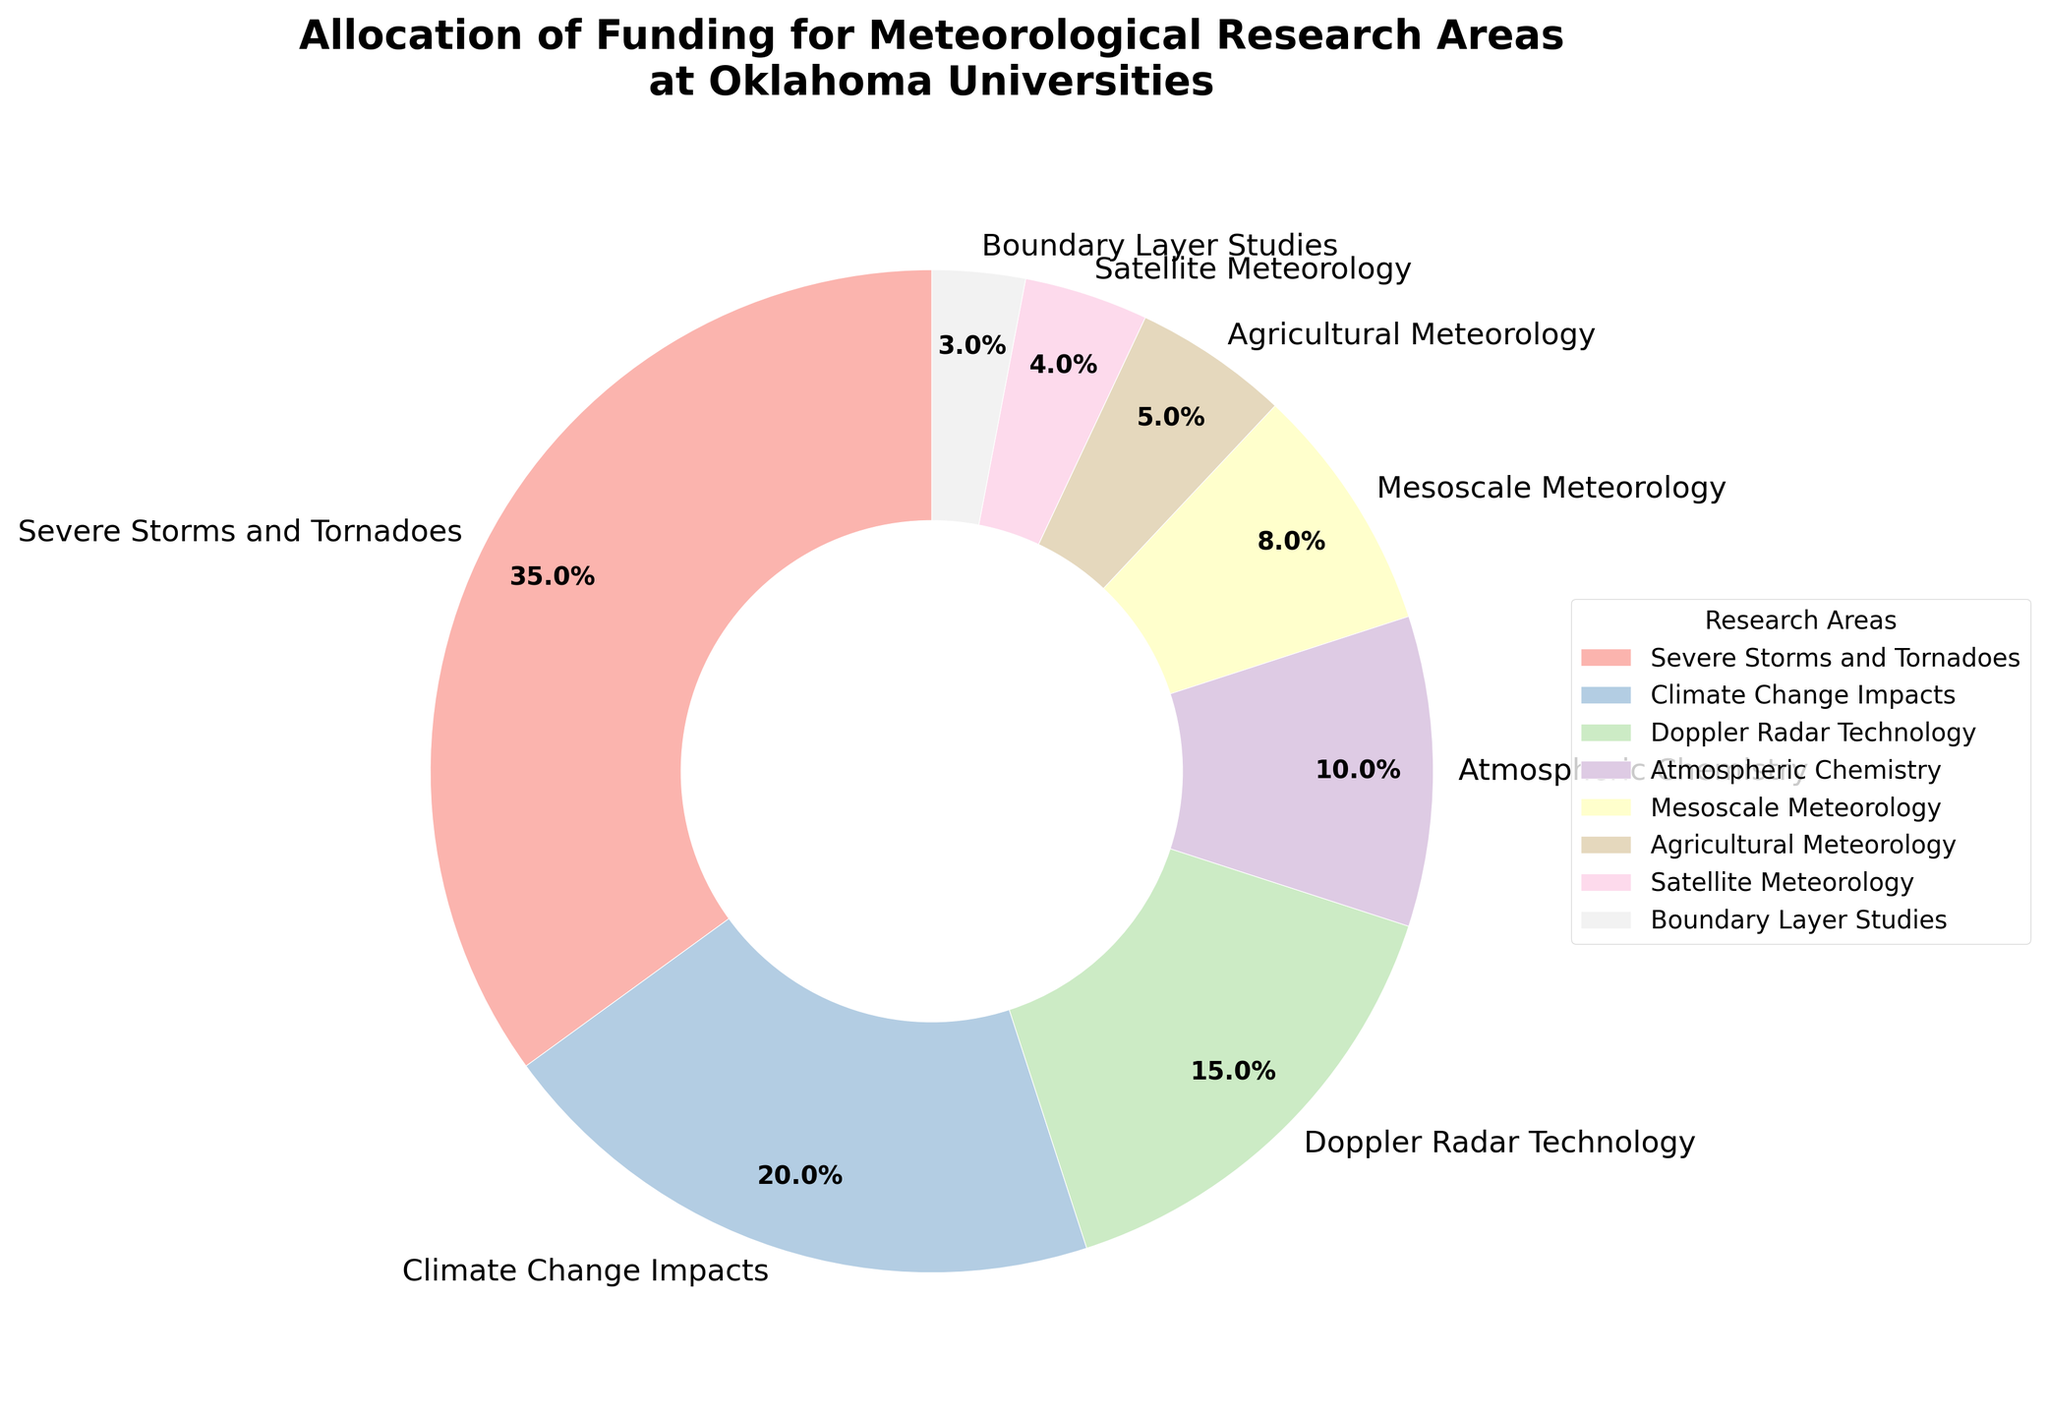Which research area received the highest funding allocation? The figure shows that Severe Storms and Tornadoes received the largest slice of the pie chart, indicating the highest funding allocation.
Answer: Severe Storms and Tornadoes Compare the funding allocations for Doppler Radar Technology and Boundary Layer Studies. Which one is higher and by how much? Doppler Radar Technology received 15% funding, while Boundary Layer Studies received 3%. The difference in allocation is 15% - 3% = 12%.
Answer: Doppler Radar Technology by 12% What is the combined funding allocation for Climate Change Impacts and Agricultural Meteorology? We sum the percentages for Climate Change Impacts (20%) and Agricultural Meteorology (5%): 20% + 5% = 25%.
Answer: 25% Out of the total funding, what percentage is allocated to Mesoscale Meteorology and Satellite Meteorology combined? Adding the funding percentages for Mesoscale Meteorology (8%) and Satellite Meteorology (4%) gives: 8% + 4% = 12%.
Answer: 12% Is the funding for Atmospheric Chemistry higher or lower than for Boundary Layer Studies, and by how much? Atmospheric Chemistry has a funding allocation of 10%, while Boundary Layer Studies has 3%. The difference is 10% - 3% = 7%.
Answer: Atmospheric Chemistry by 7% Which research area received the lowest funding allocation? The smallest slice of the pie chart is for Boundary Layer Studies, which indicates the lowest funding allocation at 3%.
Answer: Boundary Layer Studies If funding for Doppler Radar Technology was increased by 5%, what would be the new funding allocation percentage for this area? The original allocation for Doppler Radar Technology is 15%. Adding 5% gives the new allocation: 15% + 5% = 20%.
Answer: 20% What is the average funding allocation for Doppler Radar Technology, Mesoscale Meteorology, and Agricultural Meteorology? The funding percentages are 15%, 8%, and 5%. The sum is 15% + 8% + 5% = 28%, and the average is 28% / 3 ≈ 9.33%.
Answer: 9.33% How does the funding allocation for Severe Storms and Tornadoes compare to the total funding allocation for Satellite Meteorology, Agricultural Meteorology, and Boundary Layer Studies combined? Severe Storms and Tornadoes has 35%. The combined allocation for Satellite Meteorology (4%), Agricultural Meteorology (5%), and Boundary Layer Studies (3%) is: 4% + 5% + 3% = 12%. Comparing the two, 35% is significantly higher than 12%.
Answer: Severe Storms and Tornadoes is higher by 23% What is the ratio of funding allocations between Severe Storms and Tornadoes and Climate Change Impacts? The funding for Severe Storms and Tornadoes is 35%, and for Climate Change Impacts it is 20%. The ratio is 35% / 20% = 1.75.
Answer: 1.75 